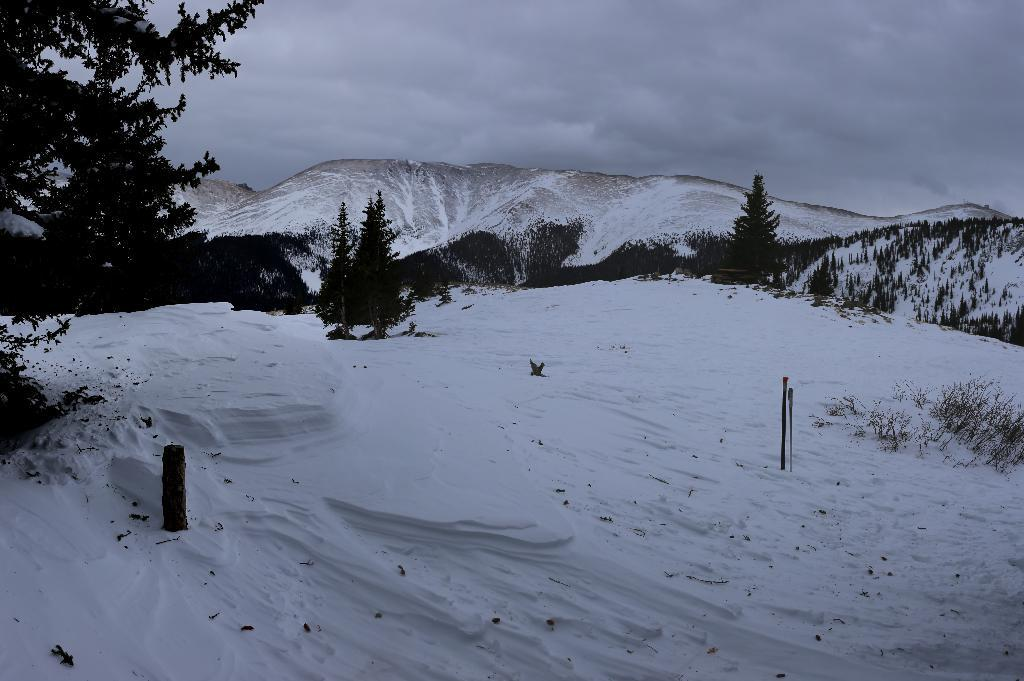What type of natural landscape is depicted in the image? The image features snowy mountains. What other natural elements can be seen in the image? There are trees with branches and leaves, as well as snow visible in the image. What is visible in the background of the image? The sky is visible in the image. Which famous actor can be seen walking along the snowy mountains in the image? There are no actors present in the image; it features natural landscapes only. What type of vegetable is growing in the snowy mountains in the image? There are no vegetables present in the image; it features natural landscapes only. 